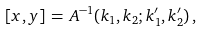<formula> <loc_0><loc_0><loc_500><loc_500>[ x , y ] \, = \, A ^ { - 1 } ( k _ { 1 } , k _ { 2 } ; k _ { 1 } ^ { \prime } , k _ { 2 } ^ { \prime } ) \, ,</formula> 